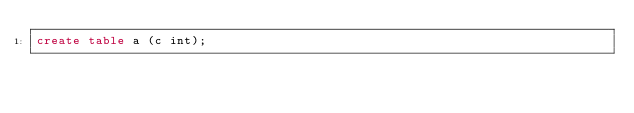<code> <loc_0><loc_0><loc_500><loc_500><_SQL_>create table a (c int);
</code> 